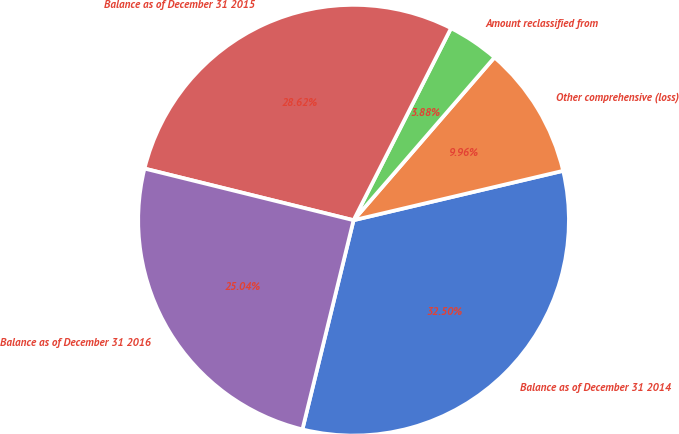<chart> <loc_0><loc_0><loc_500><loc_500><pie_chart><fcel>Balance as of December 31 2014<fcel>Other comprehensive (loss)<fcel>Amount reclassified from<fcel>Balance as of December 31 2015<fcel>Balance as of December 31 2016<nl><fcel>32.5%<fcel>9.96%<fcel>3.88%<fcel>28.62%<fcel>25.04%<nl></chart> 